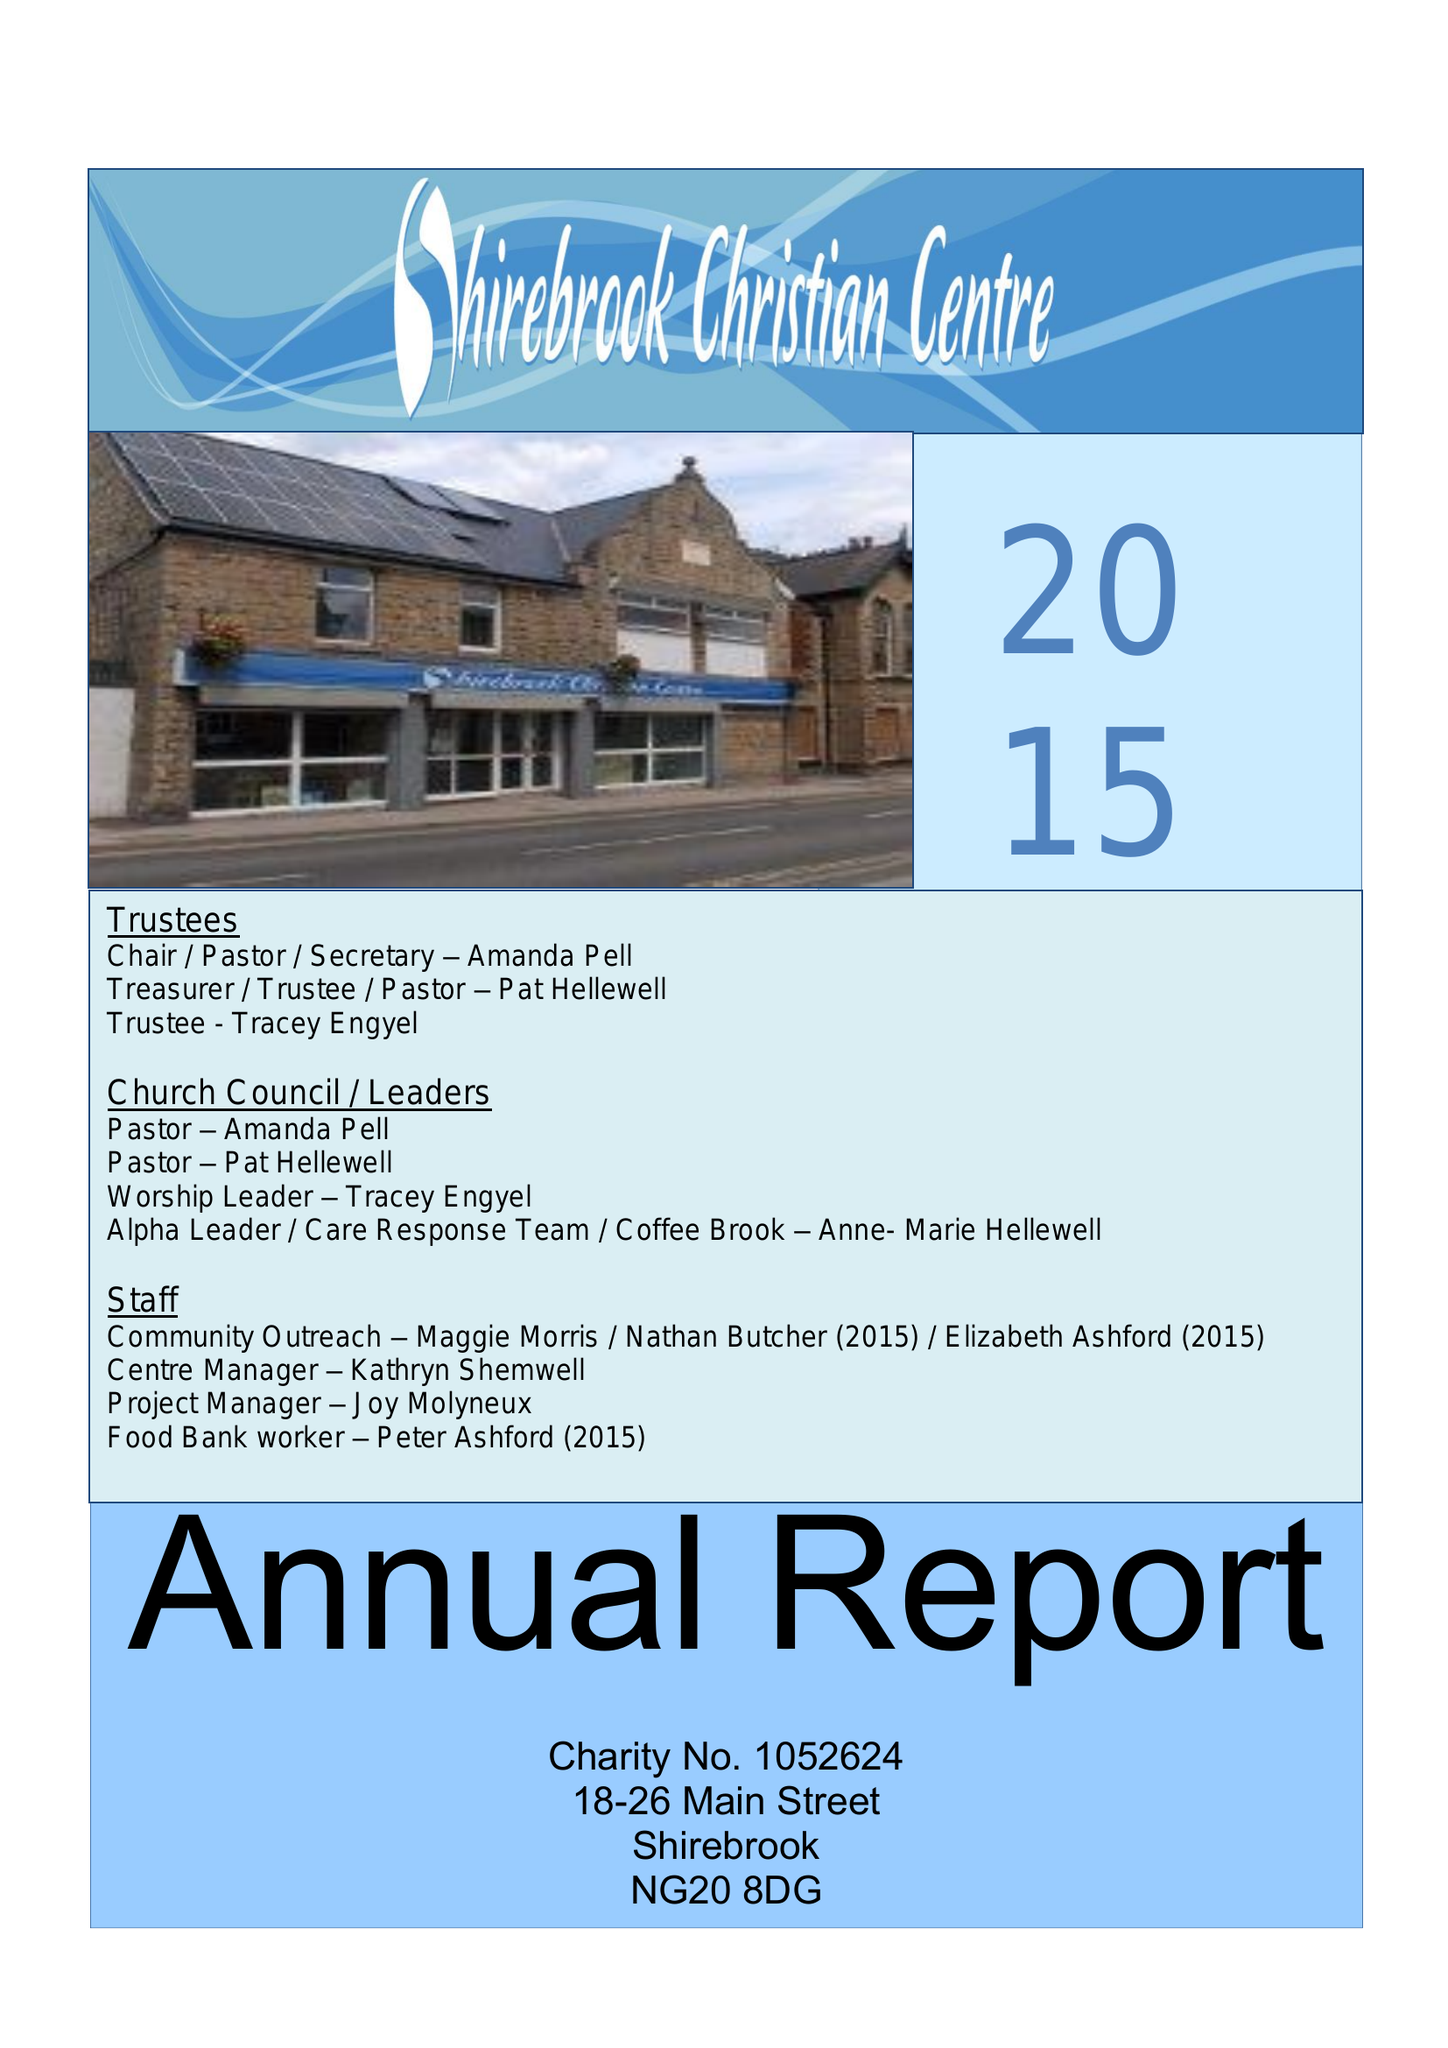What is the value for the address__street_line?
Answer the question using a single word or phrase. None 